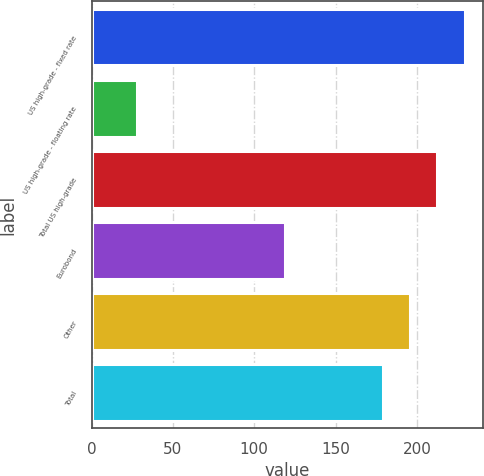Convert chart. <chart><loc_0><loc_0><loc_500><loc_500><bar_chart><fcel>US high-grade - fixed rate<fcel>US high-grade - floating rate<fcel>Total US high-grade<fcel>Eurobond<fcel>Other<fcel>Total<nl><fcel>229.4<fcel>28<fcel>212.6<fcel>119<fcel>195.8<fcel>179<nl></chart> 